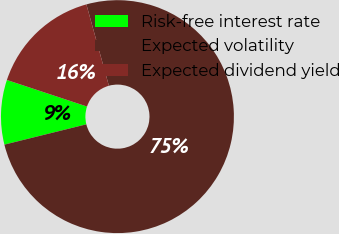<chart> <loc_0><loc_0><loc_500><loc_500><pie_chart><fcel>Risk-free interest rate<fcel>Expected volatility<fcel>Expected dividend yield<nl><fcel>8.96%<fcel>75.44%<fcel>15.61%<nl></chart> 